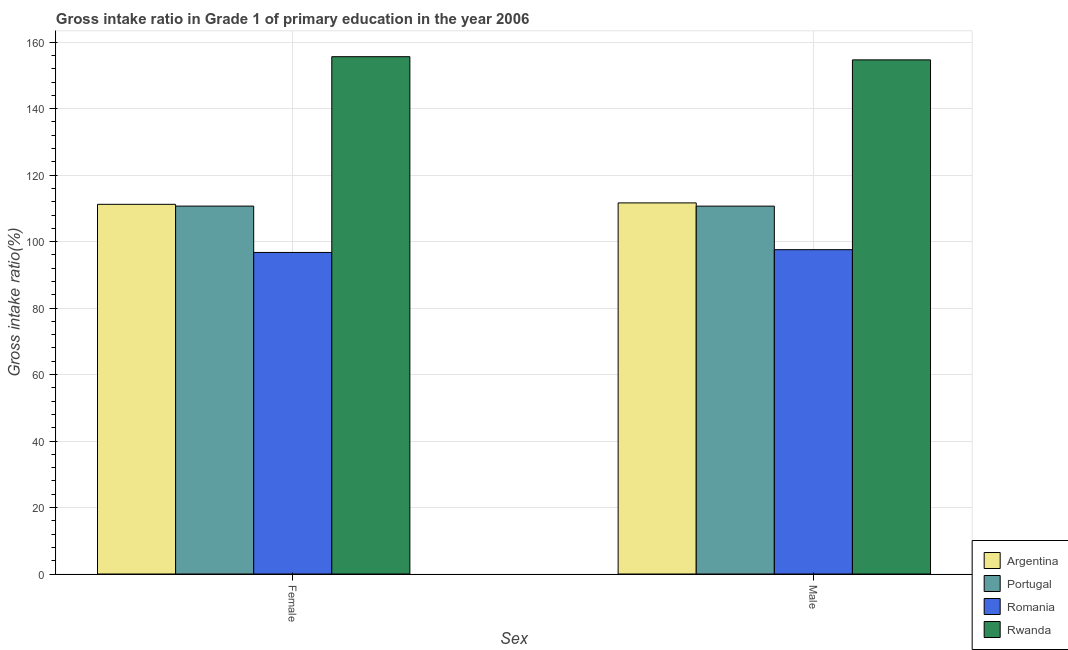How many different coloured bars are there?
Offer a terse response. 4. Are the number of bars per tick equal to the number of legend labels?
Keep it short and to the point. Yes. Are the number of bars on each tick of the X-axis equal?
Offer a very short reply. Yes. How many bars are there on the 1st tick from the right?
Keep it short and to the point. 4. What is the label of the 1st group of bars from the left?
Make the answer very short. Female. What is the gross intake ratio(female) in Rwanda?
Provide a short and direct response. 155.64. Across all countries, what is the maximum gross intake ratio(female)?
Keep it short and to the point. 155.64. Across all countries, what is the minimum gross intake ratio(male)?
Offer a terse response. 97.58. In which country was the gross intake ratio(male) maximum?
Keep it short and to the point. Rwanda. In which country was the gross intake ratio(female) minimum?
Provide a short and direct response. Romania. What is the total gross intake ratio(female) in the graph?
Your answer should be compact. 474.3. What is the difference between the gross intake ratio(male) in Portugal and that in Rwanda?
Ensure brevity in your answer.  -44. What is the difference between the gross intake ratio(male) in Portugal and the gross intake ratio(female) in Romania?
Make the answer very short. 13.93. What is the average gross intake ratio(female) per country?
Your answer should be compact. 118.58. What is the difference between the gross intake ratio(male) and gross intake ratio(female) in Romania?
Keep it short and to the point. 0.83. What is the ratio of the gross intake ratio(female) in Portugal to that in Rwanda?
Your answer should be very brief. 0.71. In how many countries, is the gross intake ratio(female) greater than the average gross intake ratio(female) taken over all countries?
Offer a very short reply. 1. What does the 3rd bar from the left in Female represents?
Provide a short and direct response. Romania. What does the 3rd bar from the right in Female represents?
Your answer should be very brief. Portugal. How many bars are there?
Provide a short and direct response. 8. What is the difference between two consecutive major ticks on the Y-axis?
Your response must be concise. 20. Does the graph contain any zero values?
Your answer should be very brief. No. What is the title of the graph?
Ensure brevity in your answer.  Gross intake ratio in Grade 1 of primary education in the year 2006. What is the label or title of the X-axis?
Offer a very short reply. Sex. What is the label or title of the Y-axis?
Make the answer very short. Gross intake ratio(%). What is the Gross intake ratio(%) of Argentina in Female?
Your answer should be compact. 111.22. What is the Gross intake ratio(%) of Portugal in Female?
Your answer should be compact. 110.69. What is the Gross intake ratio(%) of Romania in Female?
Keep it short and to the point. 96.74. What is the Gross intake ratio(%) in Rwanda in Female?
Your response must be concise. 155.64. What is the Gross intake ratio(%) in Argentina in Male?
Keep it short and to the point. 111.65. What is the Gross intake ratio(%) of Portugal in Male?
Your answer should be very brief. 110.68. What is the Gross intake ratio(%) in Romania in Male?
Your answer should be compact. 97.58. What is the Gross intake ratio(%) of Rwanda in Male?
Keep it short and to the point. 154.68. Across all Sex, what is the maximum Gross intake ratio(%) of Argentina?
Keep it short and to the point. 111.65. Across all Sex, what is the maximum Gross intake ratio(%) of Portugal?
Your answer should be compact. 110.69. Across all Sex, what is the maximum Gross intake ratio(%) of Romania?
Provide a succinct answer. 97.58. Across all Sex, what is the maximum Gross intake ratio(%) of Rwanda?
Ensure brevity in your answer.  155.64. Across all Sex, what is the minimum Gross intake ratio(%) in Argentina?
Your answer should be very brief. 111.22. Across all Sex, what is the minimum Gross intake ratio(%) of Portugal?
Provide a short and direct response. 110.68. Across all Sex, what is the minimum Gross intake ratio(%) of Romania?
Make the answer very short. 96.74. Across all Sex, what is the minimum Gross intake ratio(%) in Rwanda?
Your answer should be compact. 154.68. What is the total Gross intake ratio(%) in Argentina in the graph?
Make the answer very short. 222.88. What is the total Gross intake ratio(%) in Portugal in the graph?
Provide a succinct answer. 221.37. What is the total Gross intake ratio(%) in Romania in the graph?
Ensure brevity in your answer.  194.32. What is the total Gross intake ratio(%) of Rwanda in the graph?
Give a very brief answer. 310.32. What is the difference between the Gross intake ratio(%) of Argentina in Female and that in Male?
Ensure brevity in your answer.  -0.43. What is the difference between the Gross intake ratio(%) of Portugal in Female and that in Male?
Keep it short and to the point. 0.01. What is the difference between the Gross intake ratio(%) in Romania in Female and that in Male?
Offer a very short reply. -0.83. What is the difference between the Gross intake ratio(%) in Rwanda in Female and that in Male?
Offer a terse response. 0.96. What is the difference between the Gross intake ratio(%) in Argentina in Female and the Gross intake ratio(%) in Portugal in Male?
Keep it short and to the point. 0.55. What is the difference between the Gross intake ratio(%) in Argentina in Female and the Gross intake ratio(%) in Romania in Male?
Provide a succinct answer. 13.65. What is the difference between the Gross intake ratio(%) of Argentina in Female and the Gross intake ratio(%) of Rwanda in Male?
Offer a terse response. -43.46. What is the difference between the Gross intake ratio(%) in Portugal in Female and the Gross intake ratio(%) in Romania in Male?
Your answer should be compact. 13.11. What is the difference between the Gross intake ratio(%) in Portugal in Female and the Gross intake ratio(%) in Rwanda in Male?
Provide a short and direct response. -43.99. What is the difference between the Gross intake ratio(%) in Romania in Female and the Gross intake ratio(%) in Rwanda in Male?
Provide a succinct answer. -57.94. What is the average Gross intake ratio(%) of Argentina per Sex?
Make the answer very short. 111.44. What is the average Gross intake ratio(%) of Portugal per Sex?
Your response must be concise. 110.68. What is the average Gross intake ratio(%) in Romania per Sex?
Your answer should be very brief. 97.16. What is the average Gross intake ratio(%) of Rwanda per Sex?
Keep it short and to the point. 155.16. What is the difference between the Gross intake ratio(%) in Argentina and Gross intake ratio(%) in Portugal in Female?
Your answer should be compact. 0.53. What is the difference between the Gross intake ratio(%) in Argentina and Gross intake ratio(%) in Romania in Female?
Ensure brevity in your answer.  14.48. What is the difference between the Gross intake ratio(%) of Argentina and Gross intake ratio(%) of Rwanda in Female?
Offer a terse response. -44.42. What is the difference between the Gross intake ratio(%) in Portugal and Gross intake ratio(%) in Romania in Female?
Your response must be concise. 13.95. What is the difference between the Gross intake ratio(%) of Portugal and Gross intake ratio(%) of Rwanda in Female?
Your answer should be very brief. -44.95. What is the difference between the Gross intake ratio(%) of Romania and Gross intake ratio(%) of Rwanda in Female?
Offer a terse response. -58.9. What is the difference between the Gross intake ratio(%) of Argentina and Gross intake ratio(%) of Portugal in Male?
Offer a terse response. 0.97. What is the difference between the Gross intake ratio(%) of Argentina and Gross intake ratio(%) of Romania in Male?
Your answer should be compact. 14.08. What is the difference between the Gross intake ratio(%) in Argentina and Gross intake ratio(%) in Rwanda in Male?
Provide a succinct answer. -43.03. What is the difference between the Gross intake ratio(%) in Portugal and Gross intake ratio(%) in Romania in Male?
Your answer should be very brief. 13.1. What is the difference between the Gross intake ratio(%) in Portugal and Gross intake ratio(%) in Rwanda in Male?
Your response must be concise. -44. What is the difference between the Gross intake ratio(%) of Romania and Gross intake ratio(%) of Rwanda in Male?
Make the answer very short. -57.11. What is the ratio of the Gross intake ratio(%) of Portugal in Female to that in Male?
Give a very brief answer. 1. What is the difference between the highest and the second highest Gross intake ratio(%) in Argentina?
Your answer should be compact. 0.43. What is the difference between the highest and the second highest Gross intake ratio(%) in Portugal?
Keep it short and to the point. 0.01. What is the difference between the highest and the second highest Gross intake ratio(%) of Romania?
Provide a succinct answer. 0.83. What is the difference between the highest and the second highest Gross intake ratio(%) of Rwanda?
Your answer should be compact. 0.96. What is the difference between the highest and the lowest Gross intake ratio(%) of Argentina?
Your answer should be very brief. 0.43. What is the difference between the highest and the lowest Gross intake ratio(%) of Portugal?
Offer a very short reply. 0.01. What is the difference between the highest and the lowest Gross intake ratio(%) of Romania?
Keep it short and to the point. 0.83. 